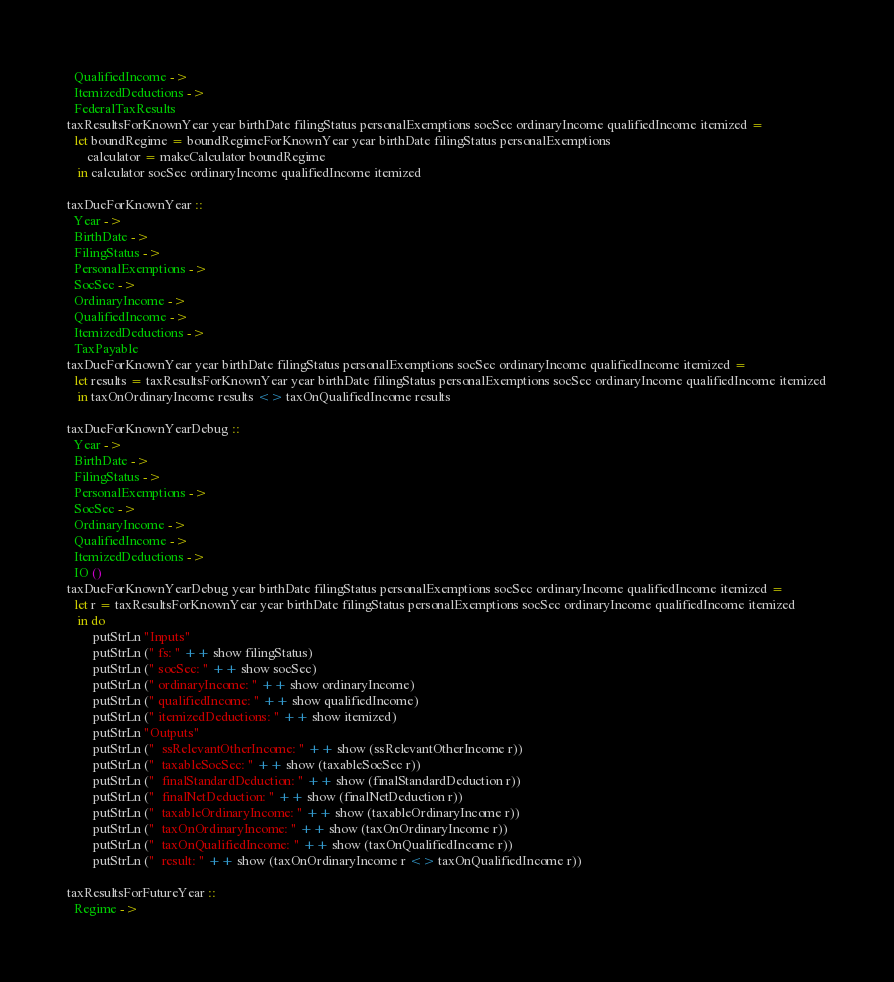Convert code to text. <code><loc_0><loc_0><loc_500><loc_500><_Haskell_>  QualifiedIncome ->
  ItemizedDeductions ->
  FederalTaxResults
taxResultsForKnownYear year birthDate filingStatus personalExemptions socSec ordinaryIncome qualifiedIncome itemized =
  let boundRegime = boundRegimeForKnownYear year birthDate filingStatus personalExemptions
      calculator = makeCalculator boundRegime
   in calculator socSec ordinaryIncome qualifiedIncome itemized

taxDueForKnownYear ::
  Year ->
  BirthDate ->
  FilingStatus ->
  PersonalExemptions ->
  SocSec ->
  OrdinaryIncome ->
  QualifiedIncome ->
  ItemizedDeductions ->
  TaxPayable
taxDueForKnownYear year birthDate filingStatus personalExemptions socSec ordinaryIncome qualifiedIncome itemized =
  let results = taxResultsForKnownYear year birthDate filingStatus personalExemptions socSec ordinaryIncome qualifiedIncome itemized
   in taxOnOrdinaryIncome results <> taxOnQualifiedIncome results

taxDueForKnownYearDebug ::
  Year ->
  BirthDate ->
  FilingStatus ->
  PersonalExemptions ->
  SocSec ->
  OrdinaryIncome ->
  QualifiedIncome ->
  ItemizedDeductions ->
  IO ()
taxDueForKnownYearDebug year birthDate filingStatus personalExemptions socSec ordinaryIncome qualifiedIncome itemized =
  let r = taxResultsForKnownYear year birthDate filingStatus personalExemptions socSec ordinaryIncome qualifiedIncome itemized
   in do
        putStrLn "Inputs"
        putStrLn (" fs: " ++ show filingStatus)
        putStrLn (" socSec: " ++ show socSec)
        putStrLn (" ordinaryIncome: " ++ show ordinaryIncome)
        putStrLn (" qualifiedIncome: " ++ show qualifiedIncome)
        putStrLn (" itemizedDeductions: " ++ show itemized)
        putStrLn "Outputs"
        putStrLn ("  ssRelevantOtherIncome: " ++ show (ssRelevantOtherIncome r))
        putStrLn ("  taxableSocSec: " ++ show (taxableSocSec r))
        putStrLn ("  finalStandardDeduction: " ++ show (finalStandardDeduction r))
        putStrLn ("  finalNetDeduction: " ++ show (finalNetDeduction r))
        putStrLn ("  taxableOrdinaryIncome: " ++ show (taxableOrdinaryIncome r))
        putStrLn ("  taxOnOrdinaryIncome: " ++ show (taxOnOrdinaryIncome r))
        putStrLn ("  taxOnQualifiedIncome: " ++ show (taxOnQualifiedIncome r))
        putStrLn ("  result: " ++ show (taxOnOrdinaryIncome r <> taxOnQualifiedIncome r))

taxResultsForFutureYear ::
  Regime -></code> 